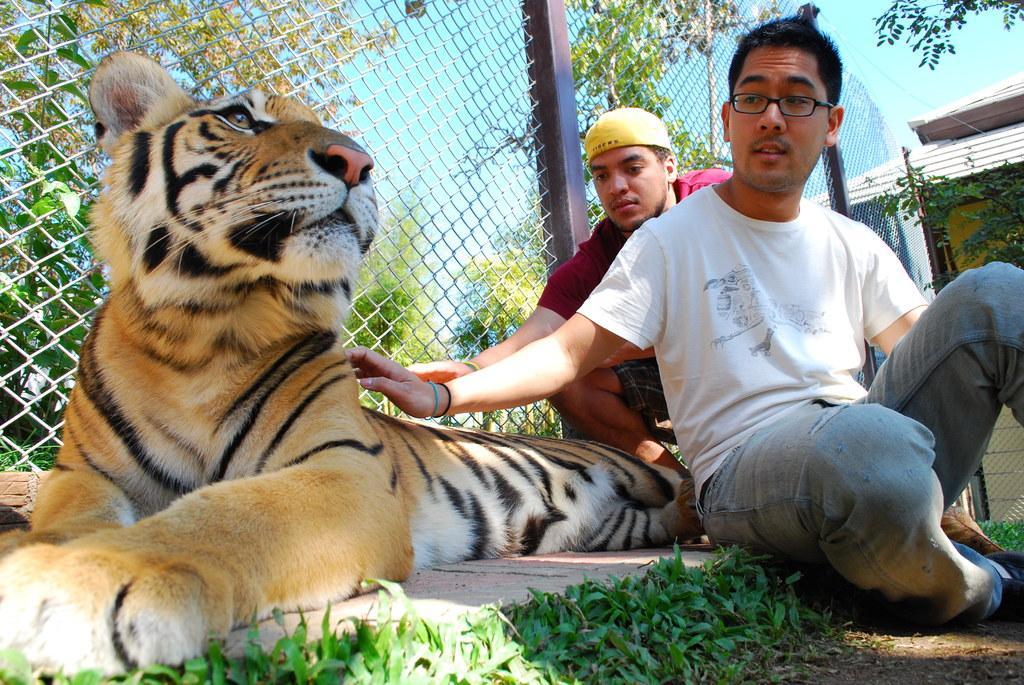In one or two sentences, can you explain what this image depicts? In this image we can see ,there are two people sitting on the right side ,and there is a tiger sitting on the ground. 